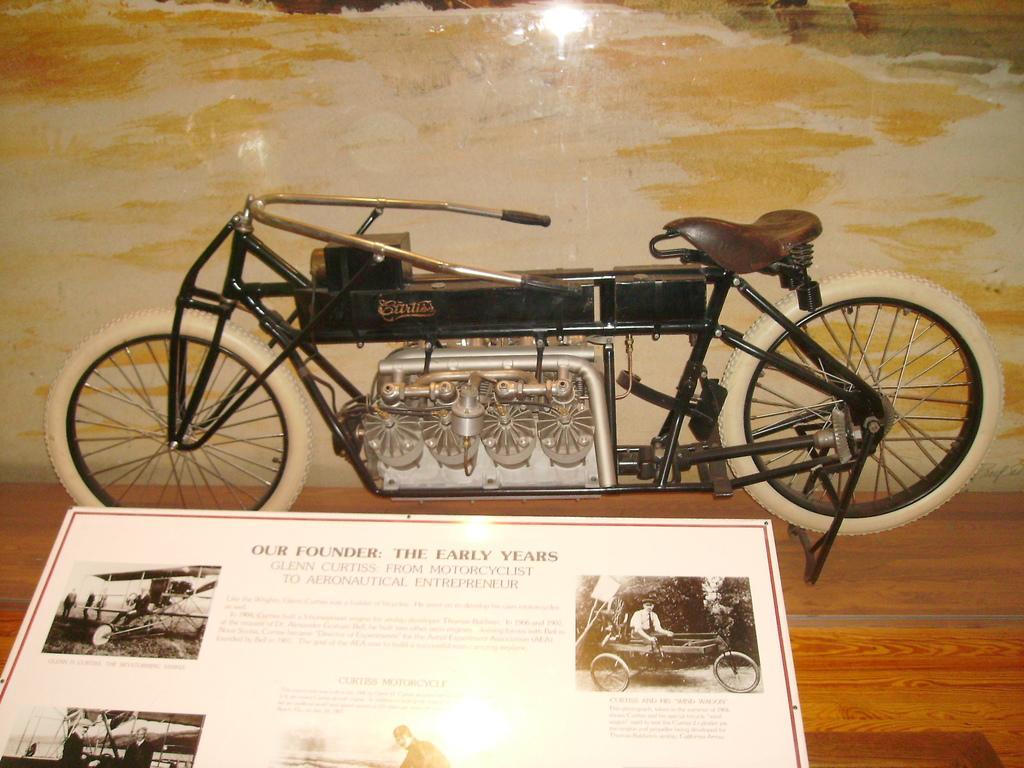How would you summarize this image in a sentence or two? In this picture, I can see a toy bicycle on the table and I can see a board with some text and pictures on it. 